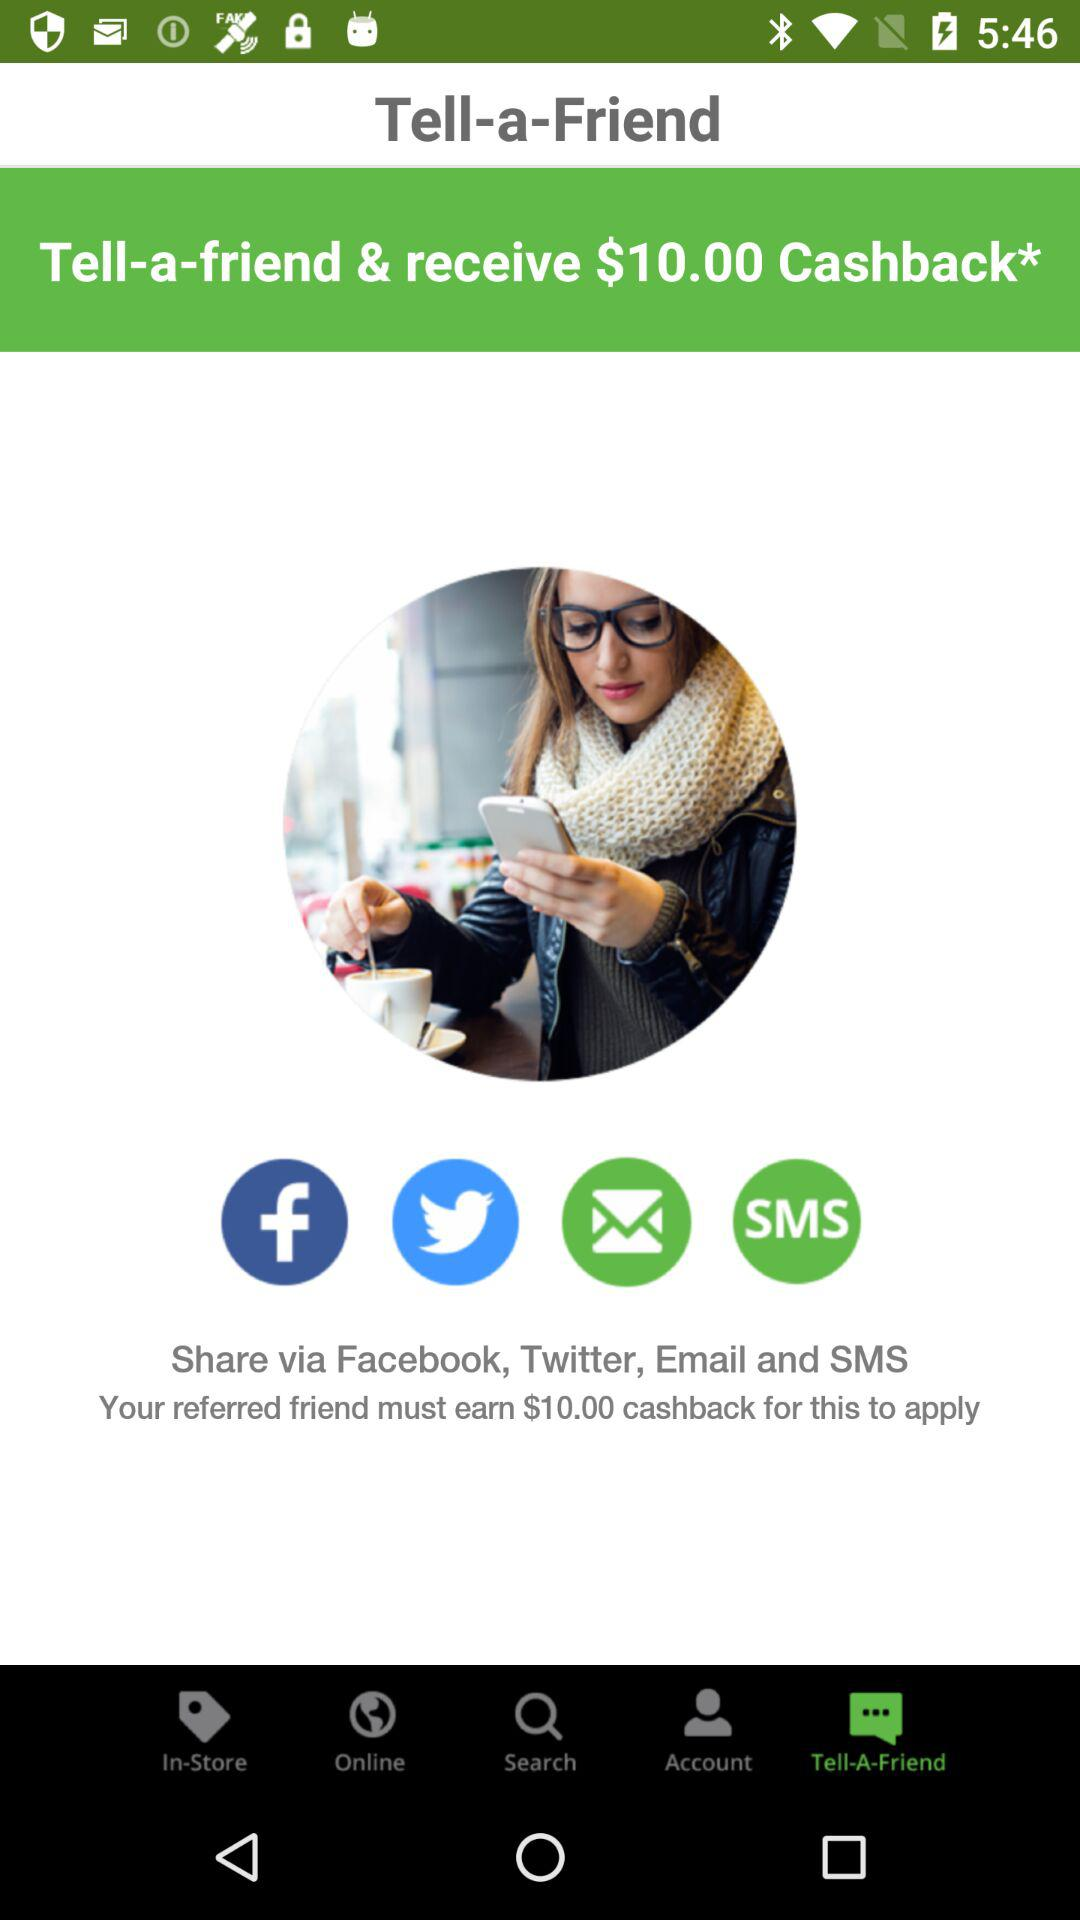Which are the different options to share? The different options to share are "Facebook", "Twitter ", "Email" and "SMS". 